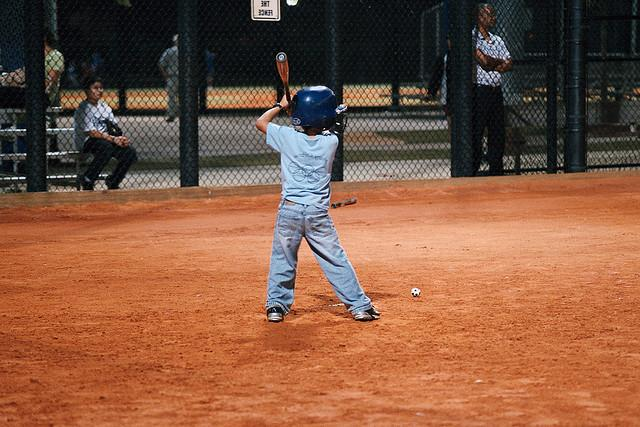What part of his uniform is he least likely to wear if he plays when he's older?

Choices:
A) socks
B) sneakers
C) jeans
D) watch jeans 